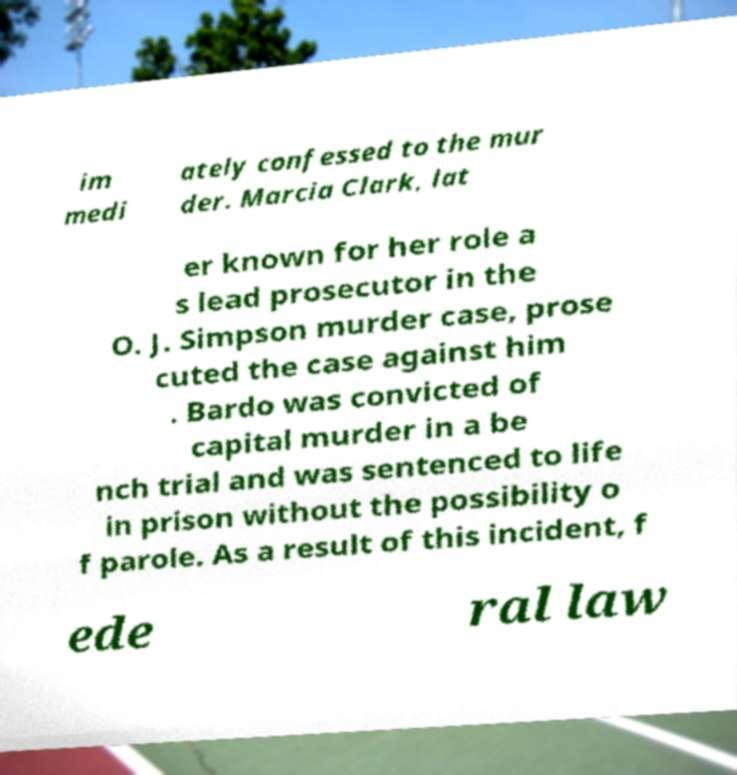There's text embedded in this image that I need extracted. Can you transcribe it verbatim? im medi ately confessed to the mur der. Marcia Clark, lat er known for her role a s lead prosecutor in the O. J. Simpson murder case, prose cuted the case against him . Bardo was convicted of capital murder in a be nch trial and was sentenced to life in prison without the possibility o f parole. As a result of this incident, f ede ral law 